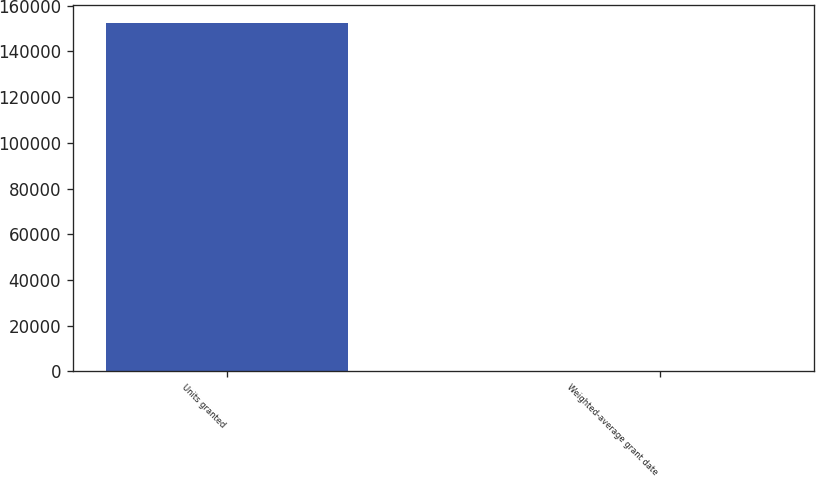Convert chart to OTSL. <chart><loc_0><loc_0><loc_500><loc_500><bar_chart><fcel>Units granted<fcel>Weighted-average grant date<nl><fcel>152651<fcel>64.12<nl></chart> 